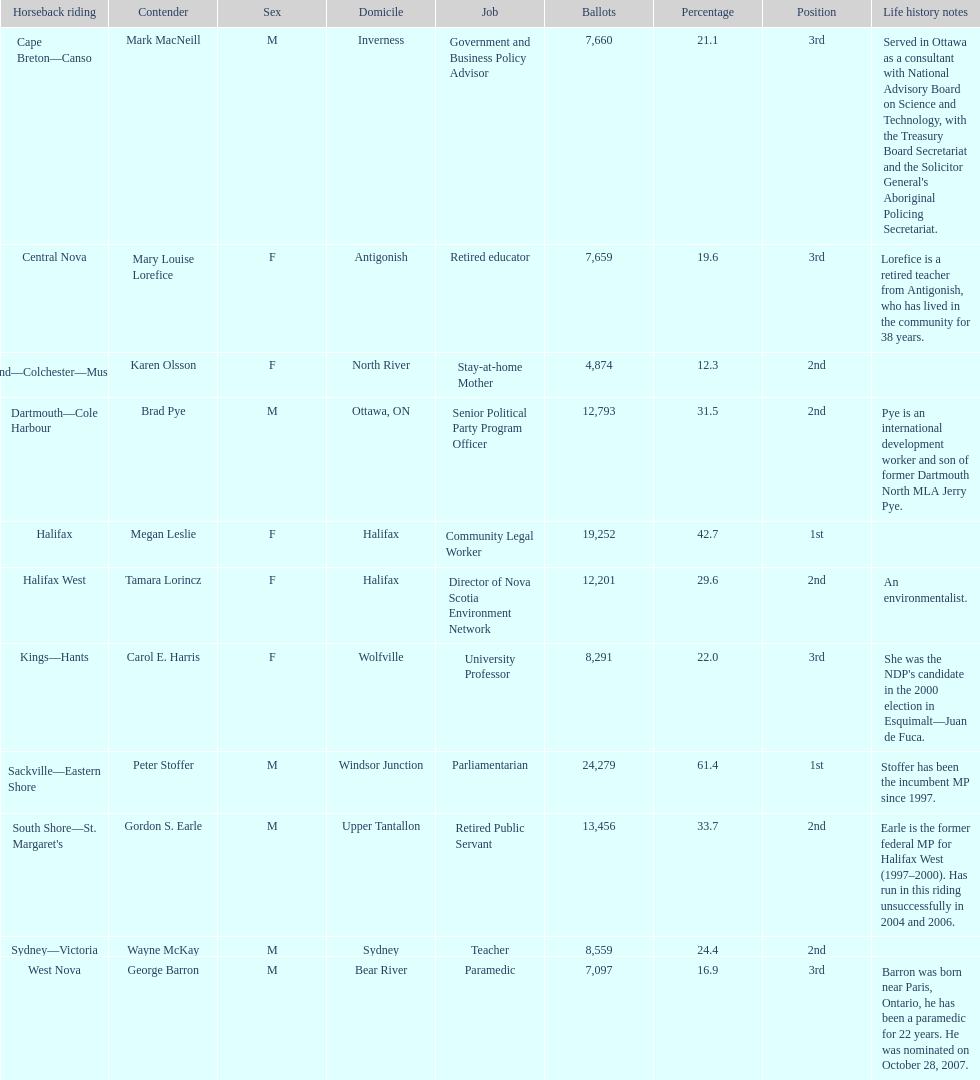Who has the most votes? Sackville-Eastern Shore. 